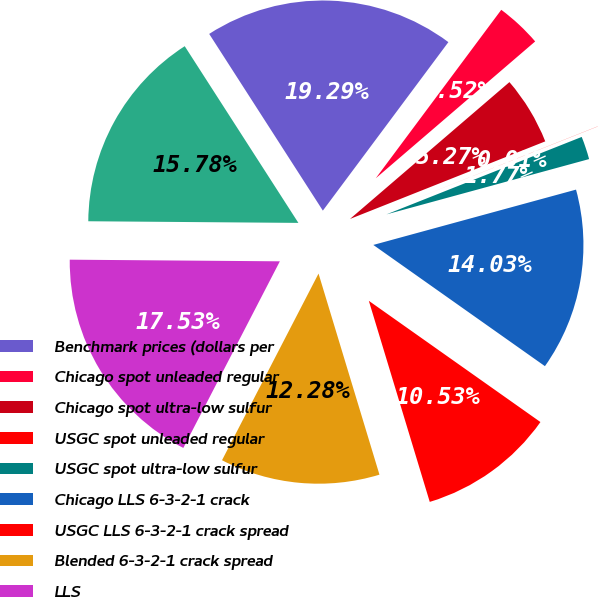<chart> <loc_0><loc_0><loc_500><loc_500><pie_chart><fcel>Benchmark prices (dollars per<fcel>Chicago spot unleaded regular<fcel>Chicago spot ultra-low sulfur<fcel>USGC spot unleaded regular<fcel>USGC spot ultra-low sulfur<fcel>Chicago LLS 6-3-2-1 crack<fcel>USGC LLS 6-3-2-1 crack spread<fcel>Blended 6-3-2-1 crack spread<fcel>LLS<fcel>WTI<nl><fcel>19.29%<fcel>3.52%<fcel>5.27%<fcel>0.01%<fcel>1.77%<fcel>14.03%<fcel>10.53%<fcel>12.28%<fcel>17.53%<fcel>15.78%<nl></chart> 